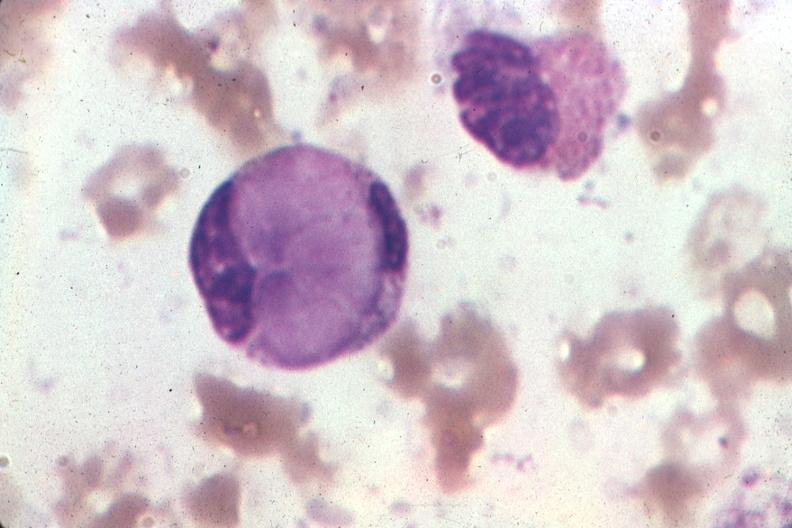s hematologic present?
Answer the question using a single word or phrase. Yes 